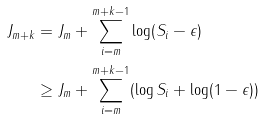<formula> <loc_0><loc_0><loc_500><loc_500>J _ { m + k } & = J _ { m } + \sum _ { i = m } ^ { m + k - 1 } \log ( S _ { i } - \epsilon ) \\ & \geq J _ { m } + \sum _ { i = m } ^ { m + k - 1 } ( \log S _ { i } + \log ( 1 - \epsilon ) )</formula> 